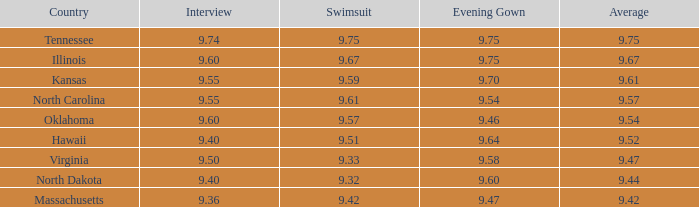57? 9.54. 